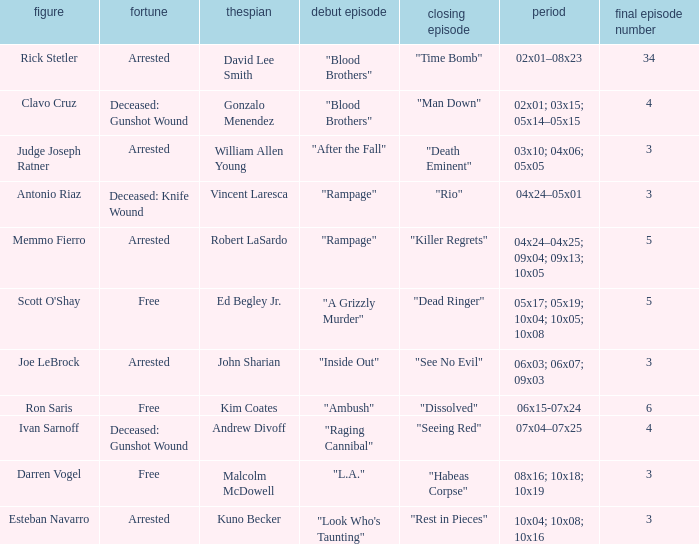What's the total number of final epbeingode count with first epbeingode being "l.a." 1.0. 